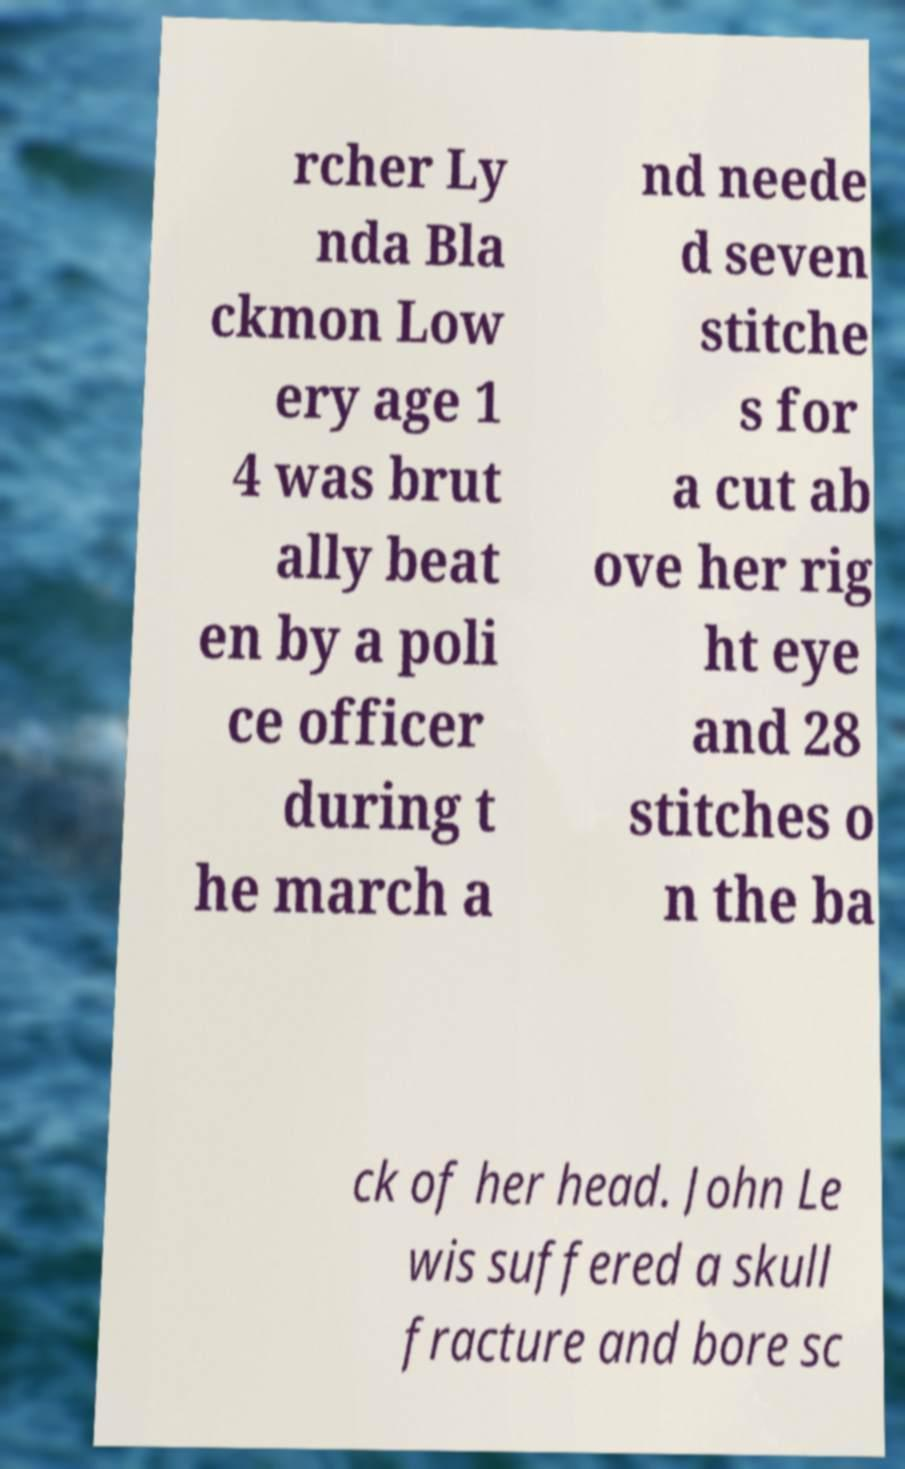Could you assist in decoding the text presented in this image and type it out clearly? rcher Ly nda Bla ckmon Low ery age 1 4 was brut ally beat en by a poli ce officer during t he march a nd neede d seven stitche s for a cut ab ove her rig ht eye and 28 stitches o n the ba ck of her head. John Le wis suffered a skull fracture and bore sc 